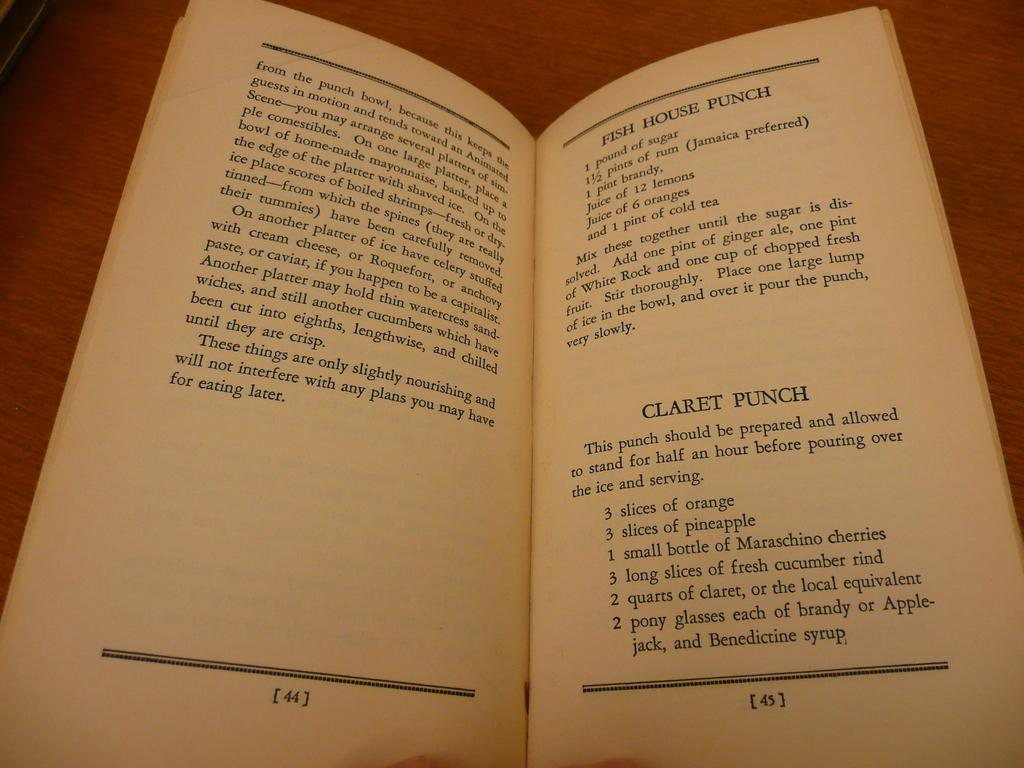Provide a one-sentence caption for the provided image. A old recipe book opened to the pages of two different punches. 